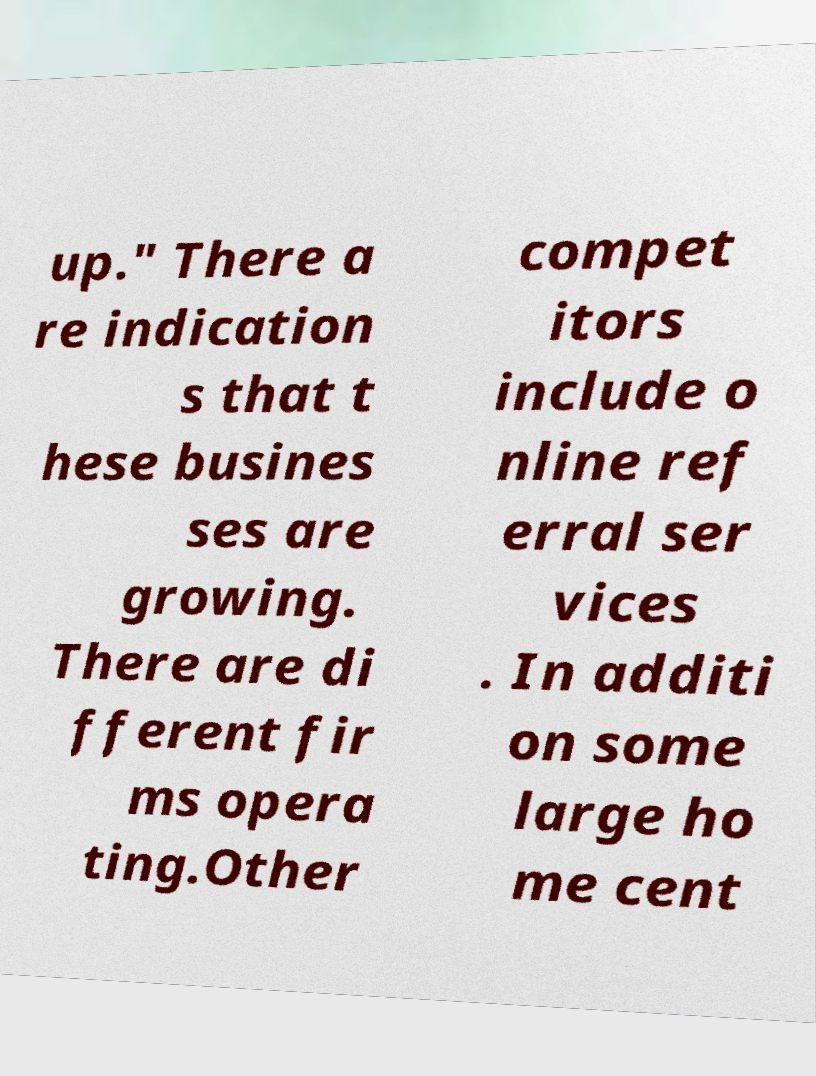Please identify and transcribe the text found in this image. up." There a re indication s that t hese busines ses are growing. There are di fferent fir ms opera ting.Other compet itors include o nline ref erral ser vices . In additi on some large ho me cent 